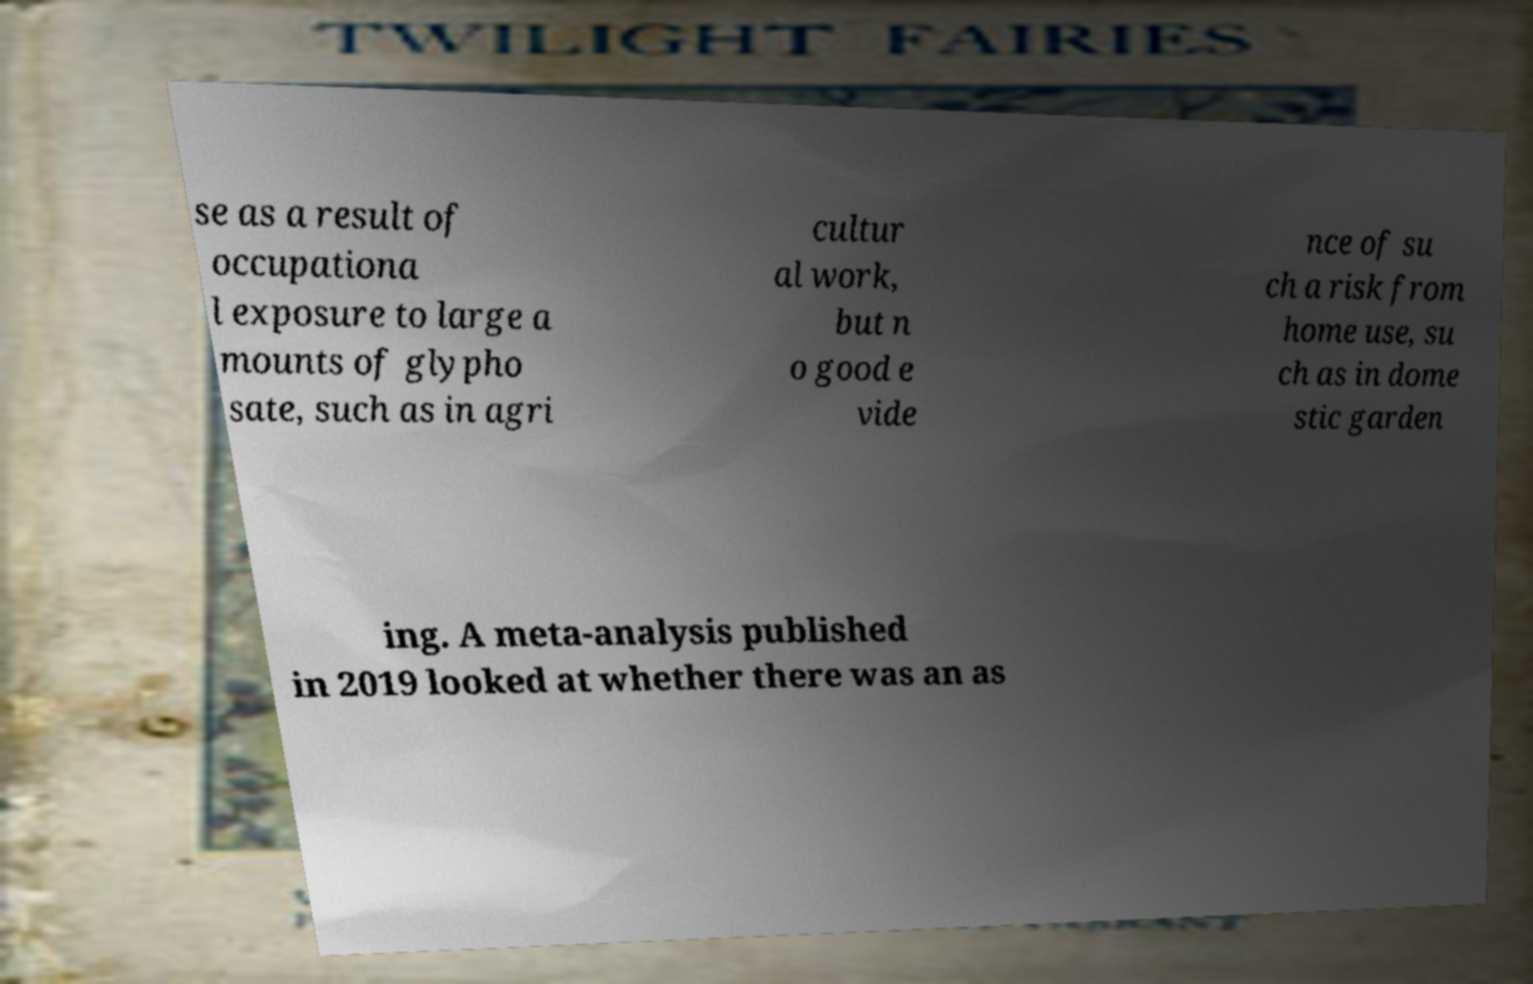I need the written content from this picture converted into text. Can you do that? se as a result of occupationa l exposure to large a mounts of glypho sate, such as in agri cultur al work, but n o good e vide nce of su ch a risk from home use, su ch as in dome stic garden ing. A meta-analysis published in 2019 looked at whether there was an as 